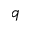Convert formula to latex. <formula><loc_0><loc_0><loc_500><loc_500>q</formula> 